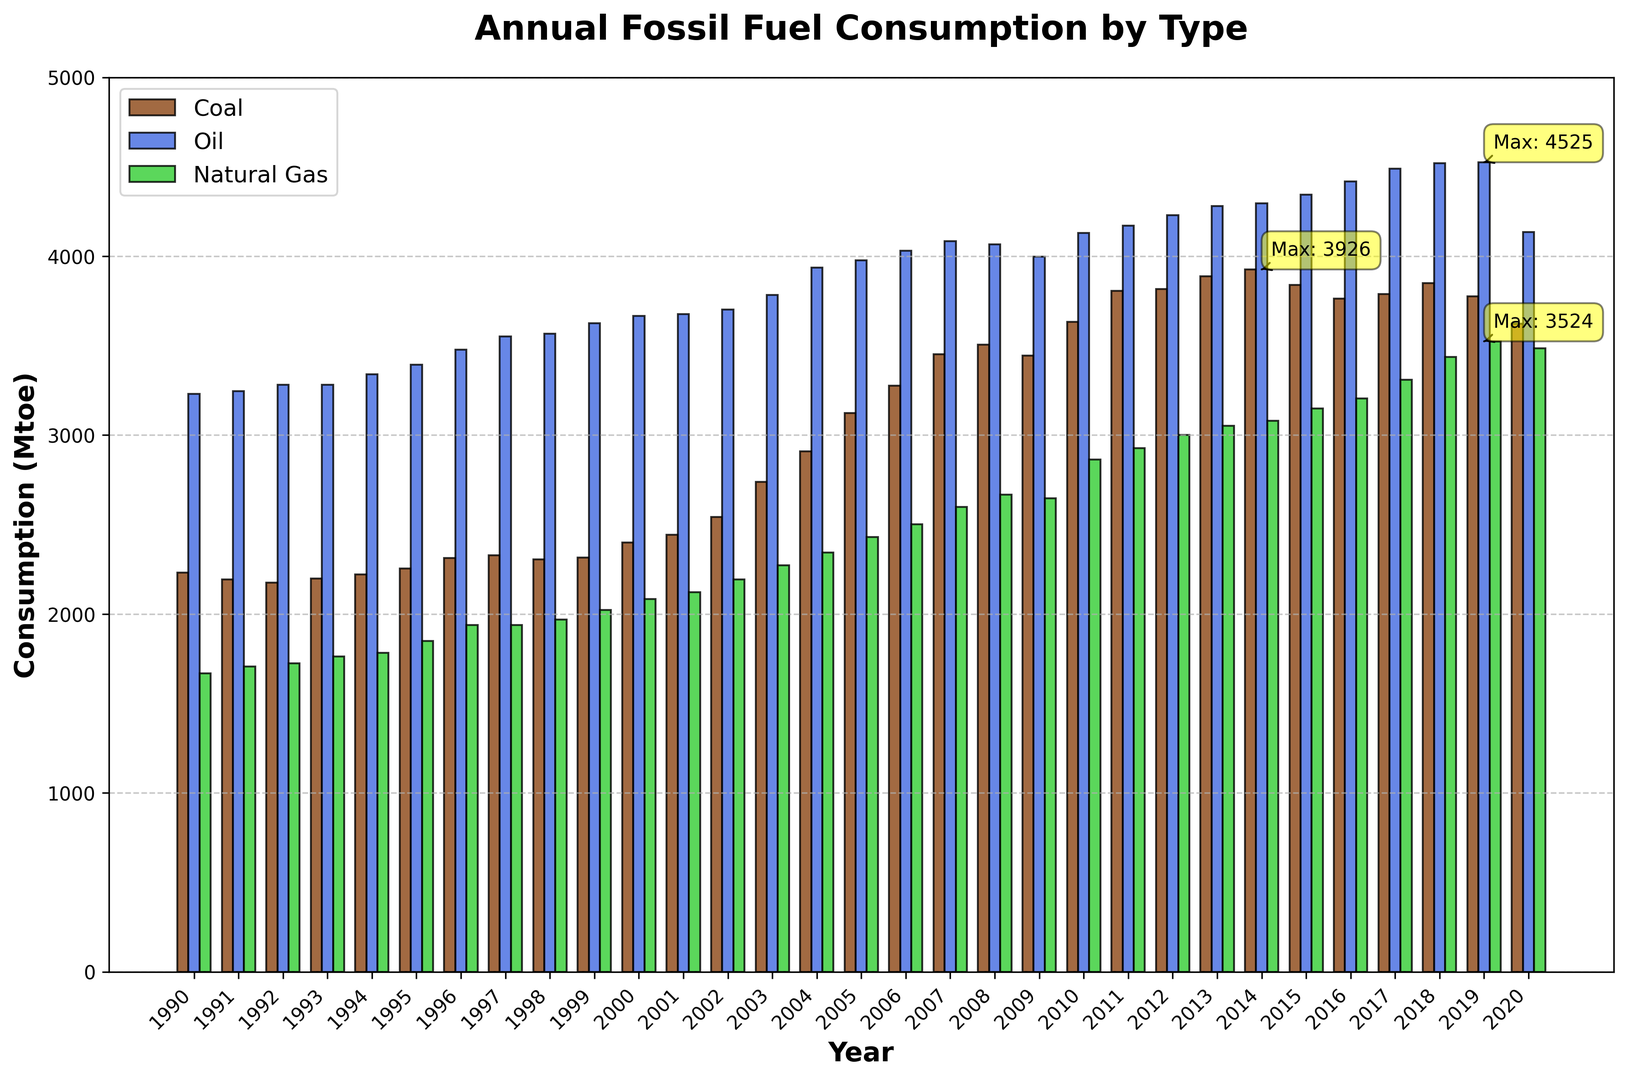What is the highest annual consumption of coal? Locate the tallest bar within the coal section (brown bars). Observe the y-axis to read off the highest value. Look for any annotation labels highlighting maximum values.
Answer: 3817 Mtoe In what year did oil consumption reach its peak, and what was the consumption rate? Locate the tallest bar within the oil section (blue bars). Then, match this bar to the corresponding year on the x-axis by following its position. Additionally, check for the annotation label indicating the maximum value.
Answer: 2019, 4525 Mtoe How does natural gas consumption in 2020 compare to its peak? Identify the bar corresponding to the year 2020 within the natural gas section (green bars), and note its height. Compare this height to the tallest green bar, which indicates the peak value.
Answer: Slightly lower than the peak Calculate the difference between coal consumption in 1990 and 2020. Find the heights of the brown bars for the years 1990 and 2020. Subtract the 2020 value from the 1990 value by observing their respective y-axis positions.
Answer: 2230 - 3623 = -393 Mtoe Which fuel type saw the most significant increase in annual consumption over the timespan shown? Examine the starting and ending heights of each type of bar (coal, oil, natural gas) from 1990 to 2020. The type with the greatest increase in height indicates the most significant increase in consumption.
Answer: Natural Gas By how much did oil consumption increase from 2000 to 2010? Identify the heights of the blue bars for the years 2000 and 2010. Subtract the 2000 value from the 2010 value by observing their respective y-axis positions.
Answer: 4130 - 3666 = 464 Mtoe What is the average annual consumption of natural gas over the last decade (2010-2020)? Identify the heights of the green bars for the years 2010 through 2020. Add these values together and divide by the number of years (11).
Answer: (2864 + 2926 + 3002 + 3051 + 3081 + 3149 + 3204 + 3309 + 3437 + 3524 + 3485) / 11 = 3184 Mtoe In what year was the consumption of coal the highest, and what was the value? Locate the tallest bar in the coal section (brown bars). Match the bar to the corresponding year on the x-axis by checking its position. Additionally, review any annotation labels indicating the maximum value.
Answer: 2013, 3887 Mtoe How much did natural gas consumption change from 2000 to 2020? Identify the heights of the green bars for the years 2000 and 2020. Subtract the 2000 value from the 2020 value by observing their respective y-axis positions.
Answer: 3485 - 2083 = 1402 Mtoe Which fossil fuel type had the smallest increase in annual consumption from 1990 to 2020, and what was the increase? Examine the starting and ending heights of each type of bar (coal, oil, natural gas) from 1990 to 2020. The type with the smallest difference in height indicates the minimal increase. Calculate the differences accordingly.
Answer: Coal, 3623 - 2230 = 1393 Mtoe 